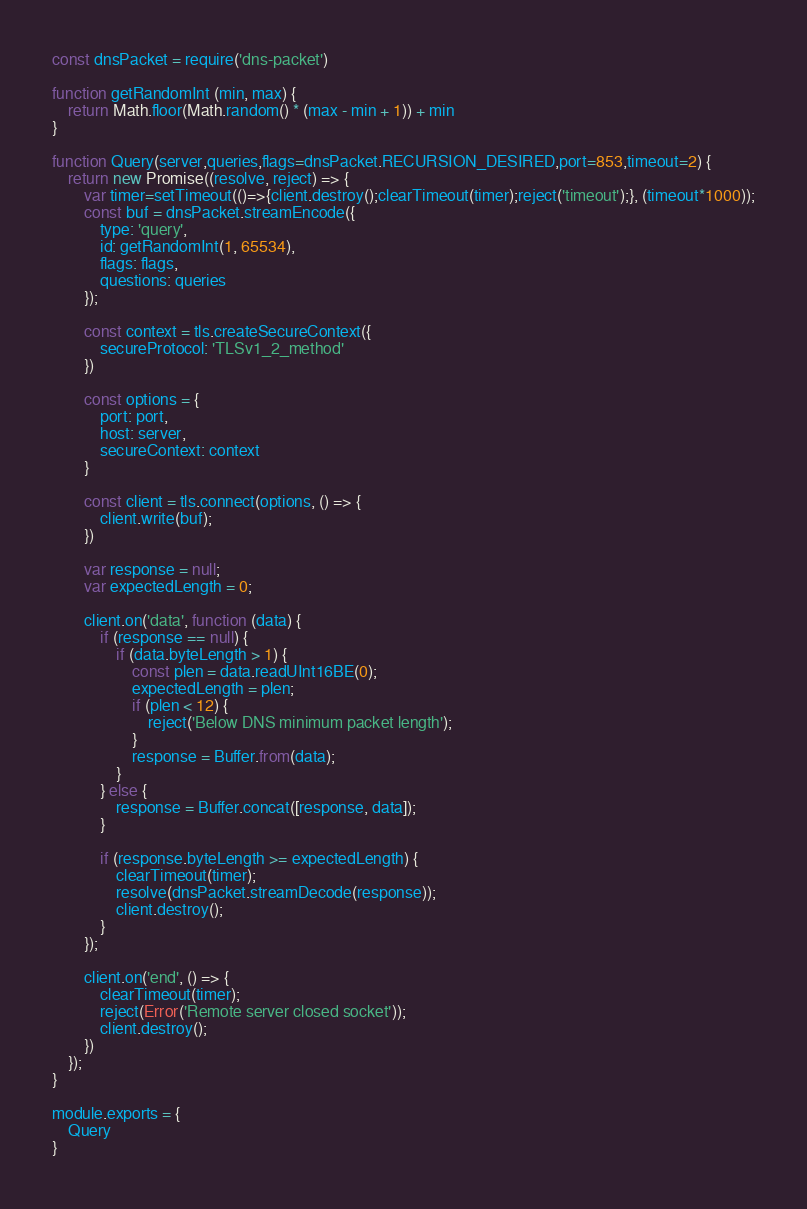<code> <loc_0><loc_0><loc_500><loc_500><_JavaScript_>const dnsPacket = require('dns-packet')

function getRandomInt (min, max) {
    return Math.floor(Math.random() * (max - min + 1)) + min
}

function Query(server,queries,flags=dnsPacket.RECURSION_DESIRED,port=853,timeout=2) {
    return new Promise((resolve, reject) => {
        var timer=setTimeout(()=>{client.destroy();clearTimeout(timer);reject('timeout');}, (timeout*1000));
        const buf = dnsPacket.streamEncode({
            type: 'query',
            id: getRandomInt(1, 65534),
            flags: flags,
            questions: queries
        });
     
        const context = tls.createSecureContext({
            secureProtocol: 'TLSv1_2_method'
        })
        
        const options = {
            port: port,
            host: server,
            secureContext: context
        }
        
        const client = tls.connect(options, () => {
            client.write(buf);
        })

        var response = null;
        var expectedLength = 0;
        
        client.on('data', function (data) {
            if (response == null) {
                if (data.byteLength > 1) {
                    const plen = data.readUInt16BE(0);
                    expectedLength = plen;
                    if (plen < 12) {
                        reject('Below DNS minimum packet length');
                    }
                    response = Buffer.from(data);
                }
            } else {
                response = Buffer.concat([response, data]);
            }
        
            if (response.byteLength >= expectedLength) {
                clearTimeout(timer);
                resolve(dnsPacket.streamDecode(response));
                client.destroy();
            }
        });
        
        client.on('end', () => {
            clearTimeout(timer);
            reject(Error('Remote server closed socket'));
            client.destroy();
        })
    });
}

module.exports = {
    Query
}</code> 